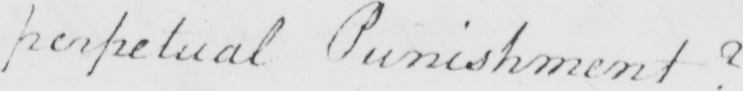Transcribe the text shown in this historical manuscript line. perpetual Punishment ? 